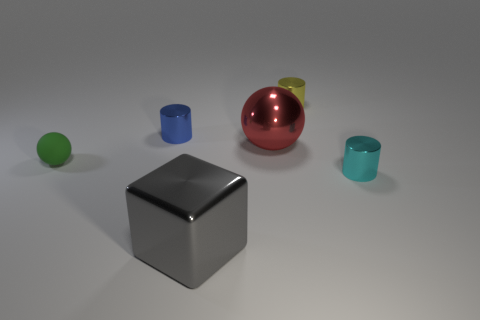How many other things are the same size as the rubber ball?
Ensure brevity in your answer.  3. What size is the shiny thing that is both behind the shiny sphere and to the left of the tiny yellow metallic cylinder?
Provide a succinct answer. Small. There is a small matte object; does it have the same color as the tiny cylinder that is left of the large red sphere?
Your answer should be compact. No. Are there any small purple rubber objects of the same shape as the blue object?
Your answer should be very brief. No. What number of objects are either purple matte cylinders or small metal things behind the large sphere?
Your answer should be compact. 2. How many other objects are there of the same material as the small yellow cylinder?
Offer a very short reply. 4. What number of things are big gray shiny cubes or yellow metallic cylinders?
Your answer should be very brief. 2. Are there more gray objects that are on the left side of the large cube than small cylinders that are right of the blue metal cylinder?
Offer a very short reply. No. Is the color of the tiny shiny thing that is right of the tiny yellow metal cylinder the same as the sphere that is on the right side of the gray metallic thing?
Make the answer very short. No. There is a ball that is on the right side of the tiny object that is to the left of the metal cylinder to the left of the tiny yellow cylinder; what size is it?
Give a very brief answer. Large. 